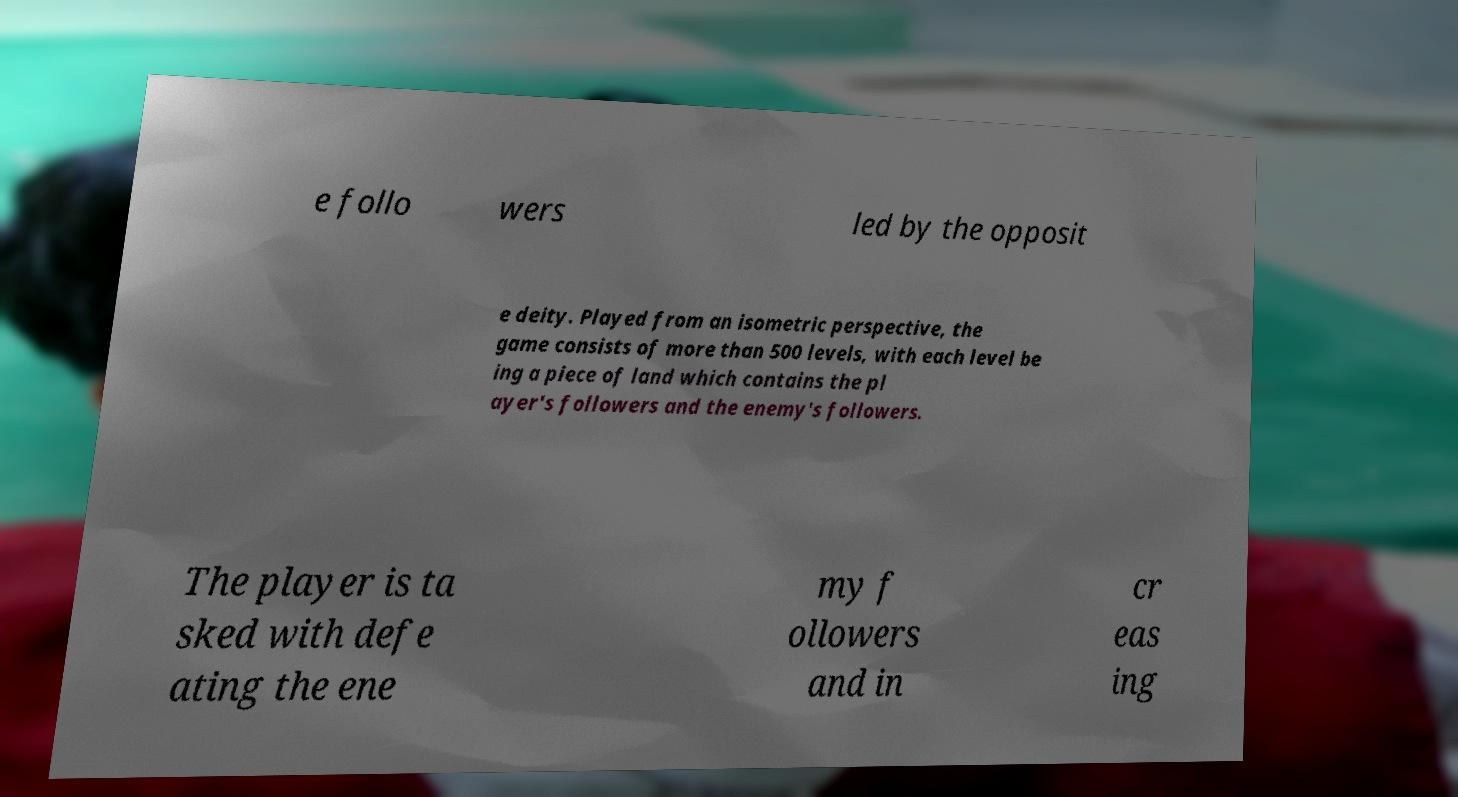Please identify and transcribe the text found in this image. e follo wers led by the opposit e deity. Played from an isometric perspective, the game consists of more than 500 levels, with each level be ing a piece of land which contains the pl ayer's followers and the enemy's followers. The player is ta sked with defe ating the ene my f ollowers and in cr eas ing 